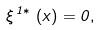<formula> <loc_0><loc_0><loc_500><loc_500>\xi ^ { \, 1 \ast } \, \left ( x \right ) = 0 ,</formula> 